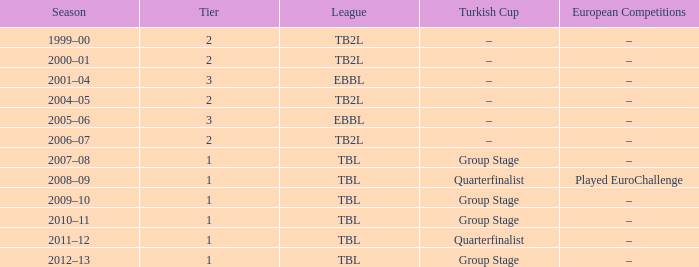In the 2004-05 season, what european events are classified as tier 2? –. 